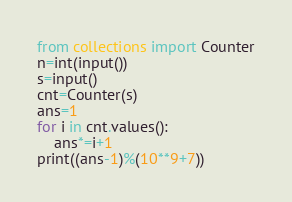Convert code to text. <code><loc_0><loc_0><loc_500><loc_500><_Python_>from collections import Counter
n=int(input())
s=input()
cnt=Counter(s)
ans=1
for i in cnt.values():
    ans*=i+1
print((ans-1)%(10**9+7))</code> 